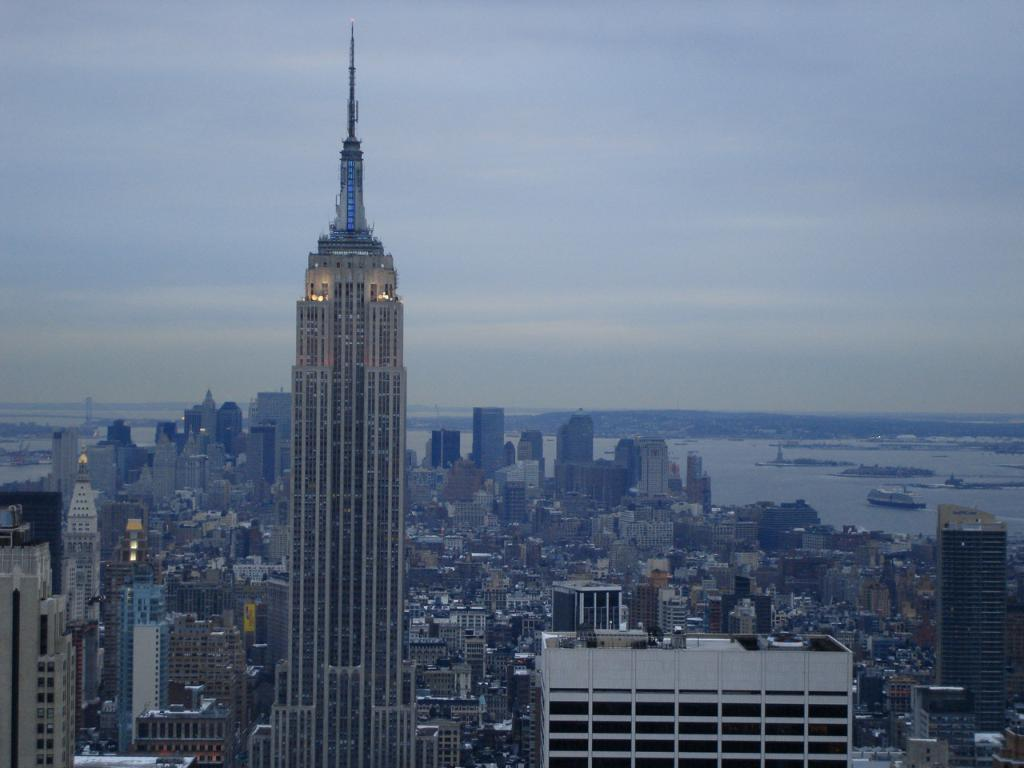What type of view is shown in the image? The image is a top angle view of the city. What structures can be seen in the image? There are buildings visible in the image. What natural element is present in the image? There is water visible in the image. What type of oil can be seen floating on the water in the image? There is no oil visible in the image; only buildings and water are present. 